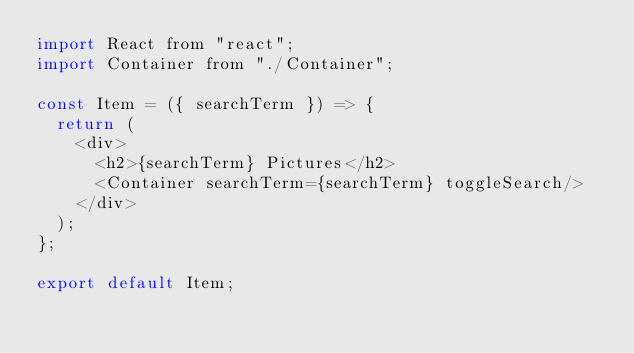Convert code to text. <code><loc_0><loc_0><loc_500><loc_500><_JavaScript_>import React from "react";
import Container from "./Container";

const Item = ({ searchTerm }) => {
  return (
    <div>
      <h2>{searchTerm} Pictures</h2>
      <Container searchTerm={searchTerm} toggleSearch/>
    </div>
  );
};

export default Item;
</code> 